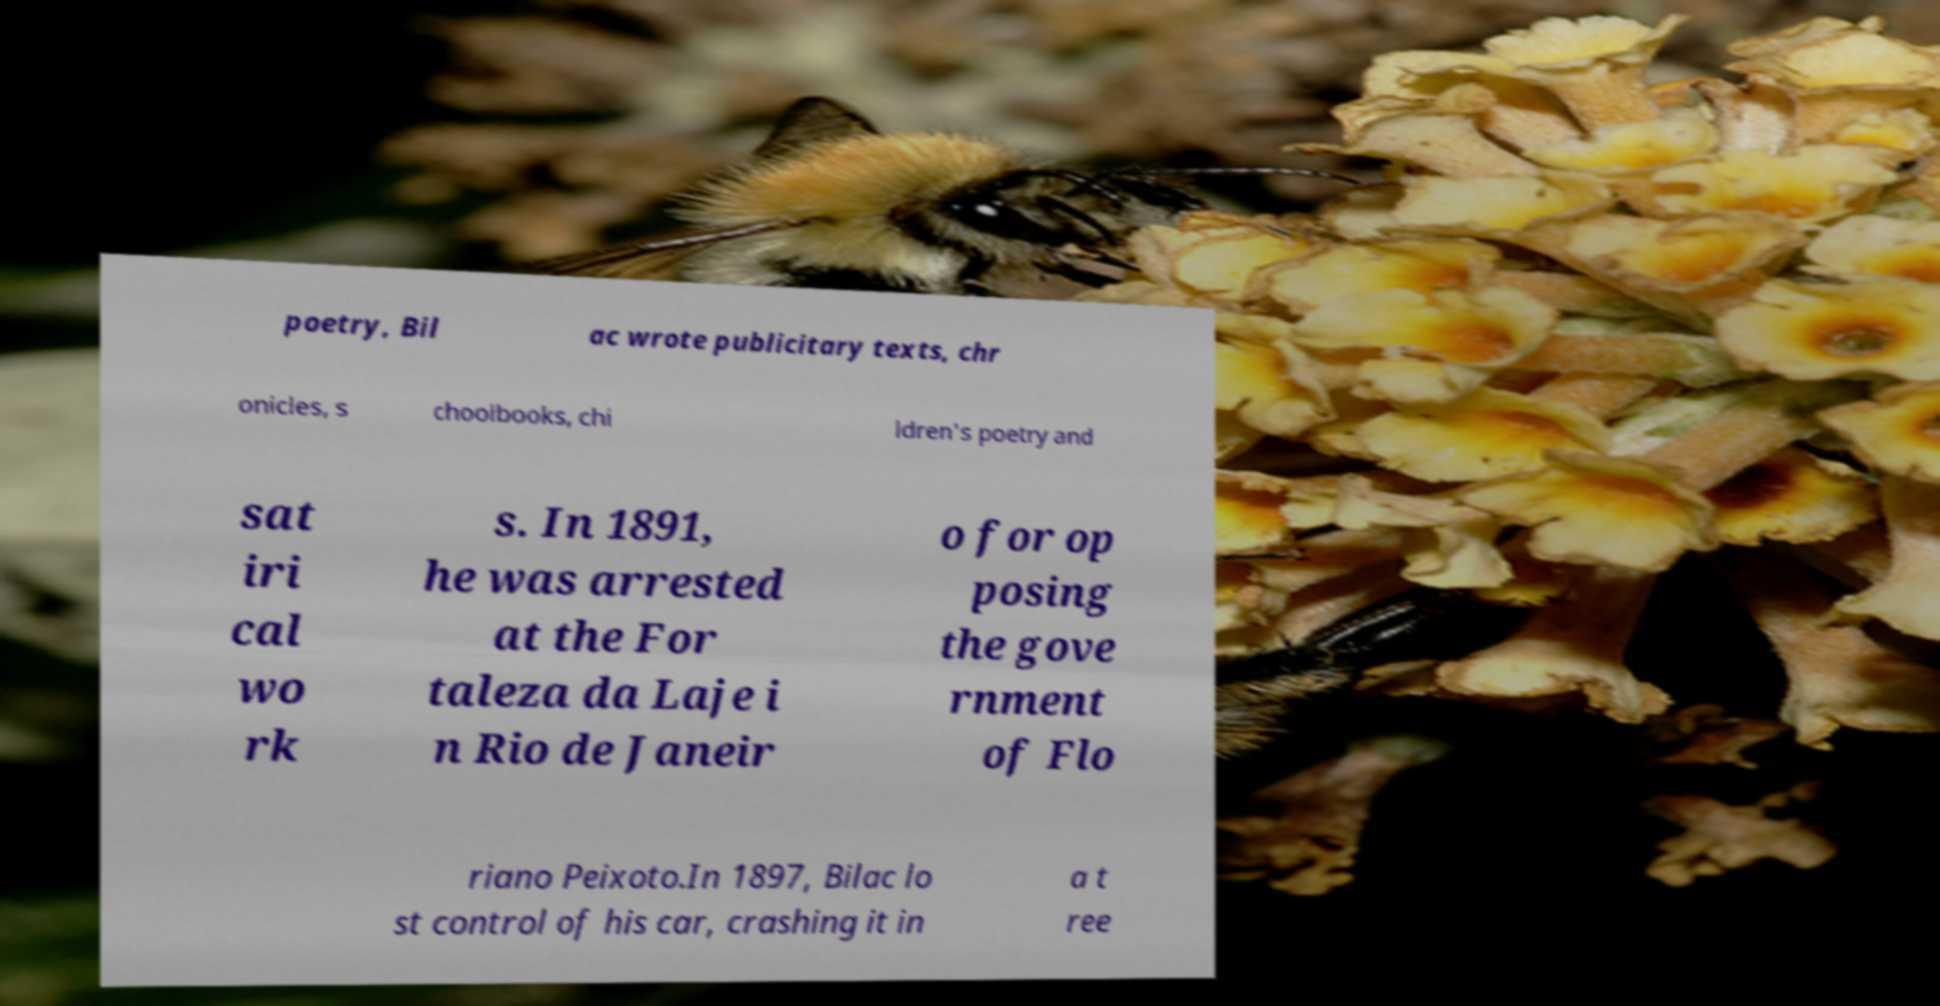There's text embedded in this image that I need extracted. Can you transcribe it verbatim? poetry, Bil ac wrote publicitary texts, chr onicles, s choolbooks, chi ldren's poetry and sat iri cal wo rk s. In 1891, he was arrested at the For taleza da Laje i n Rio de Janeir o for op posing the gove rnment of Flo riano Peixoto.In 1897, Bilac lo st control of his car, crashing it in a t ree 